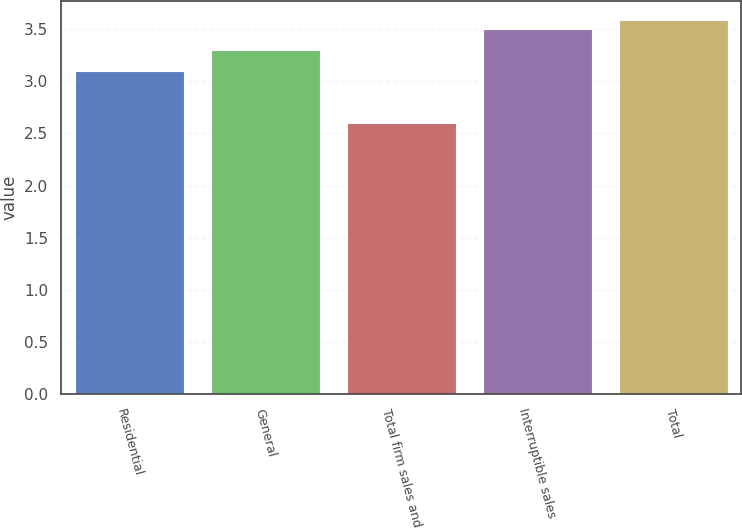Convert chart. <chart><loc_0><loc_0><loc_500><loc_500><bar_chart><fcel>Residential<fcel>General<fcel>Total firm sales and<fcel>Interruptible sales<fcel>Total<nl><fcel>3.1<fcel>3.3<fcel>2.6<fcel>3.5<fcel>3.59<nl></chart> 